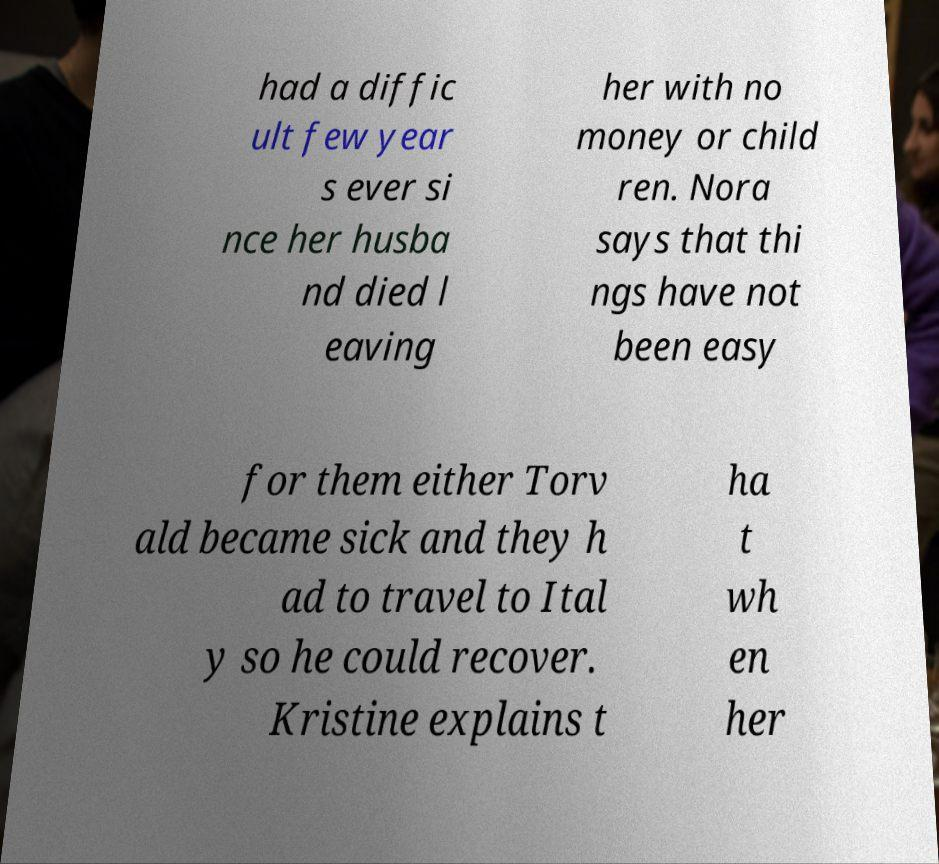Please read and relay the text visible in this image. What does it say? had a diffic ult few year s ever si nce her husba nd died l eaving her with no money or child ren. Nora says that thi ngs have not been easy for them either Torv ald became sick and they h ad to travel to Ital y so he could recover. Kristine explains t ha t wh en her 